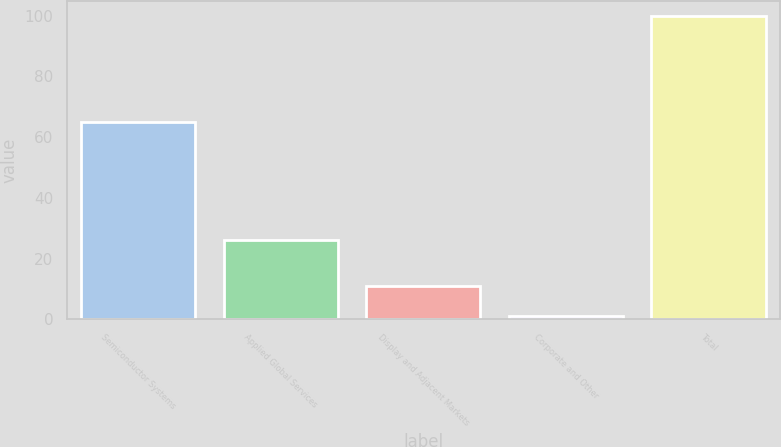Convert chart to OTSL. <chart><loc_0><loc_0><loc_500><loc_500><bar_chart><fcel>Semiconductor Systems<fcel>Applied Global Services<fcel>Display and Adjacent Markets<fcel>Corporate and Other<fcel>Total<nl><fcel>65<fcel>26<fcel>10.9<fcel>1<fcel>100<nl></chart> 